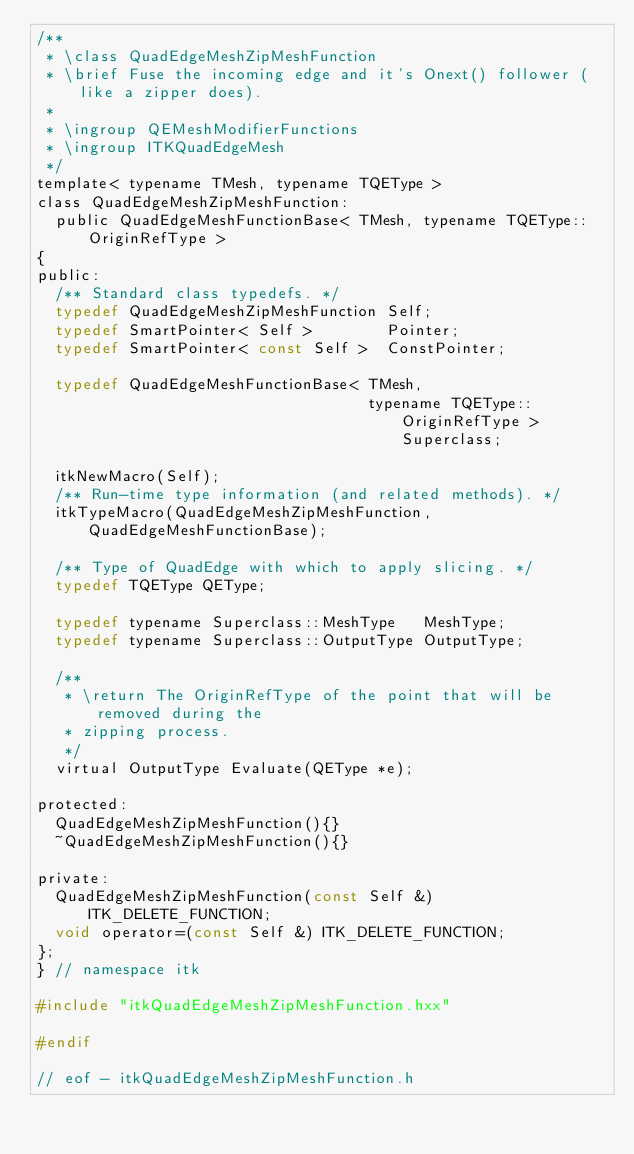Convert code to text. <code><loc_0><loc_0><loc_500><loc_500><_C_>/**
 * \class QuadEdgeMeshZipMeshFunction
 * \brief Fuse the incoming edge and it's Onext() follower (like a zipper does).
 *
 * \ingroup QEMeshModifierFunctions
 * \ingroup ITKQuadEdgeMesh
 */
template< typename TMesh, typename TQEType >
class QuadEdgeMeshZipMeshFunction:
  public QuadEdgeMeshFunctionBase< TMesh, typename TQEType::OriginRefType >
{
public:
  /** Standard class typedefs. */
  typedef QuadEdgeMeshZipMeshFunction Self;
  typedef SmartPointer< Self >        Pointer;
  typedef SmartPointer< const Self >  ConstPointer;

  typedef QuadEdgeMeshFunctionBase< TMesh,
                                    typename TQEType::OriginRefType >  Superclass;

  itkNewMacro(Self);
  /** Run-time type information (and related methods). */
  itkTypeMacro(QuadEdgeMeshZipMeshFunction, QuadEdgeMeshFunctionBase);

  /** Type of QuadEdge with which to apply slicing. */
  typedef TQEType QEType;

  typedef typename Superclass::MeshType   MeshType;
  typedef typename Superclass::OutputType OutputType;

  /**
   * \return The OriginRefType of the point that will be removed during the
   * zipping process.
   */
  virtual OutputType Evaluate(QEType *e);

protected:
  QuadEdgeMeshZipMeshFunction(){}
  ~QuadEdgeMeshZipMeshFunction(){}

private:
  QuadEdgeMeshZipMeshFunction(const Self &) ITK_DELETE_FUNCTION;
  void operator=(const Self &) ITK_DELETE_FUNCTION;
};
} // namespace itk

#include "itkQuadEdgeMeshZipMeshFunction.hxx"

#endif

// eof - itkQuadEdgeMeshZipMeshFunction.h
</code> 